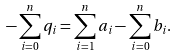<formula> <loc_0><loc_0><loc_500><loc_500>- \sum _ { i = 0 } ^ { n } q _ { i } = \sum _ { i = 1 } ^ { n } a _ { i } - \sum _ { i = 0 } ^ { n } b _ { i } .</formula> 